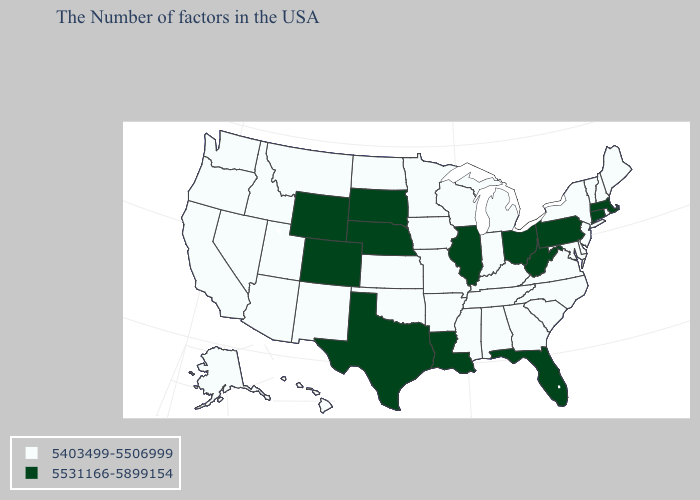What is the value of Minnesota?
Short answer required. 5403499-5506999. Name the states that have a value in the range 5403499-5506999?
Short answer required. Maine, Rhode Island, New Hampshire, Vermont, New York, New Jersey, Delaware, Maryland, Virginia, North Carolina, South Carolina, Georgia, Michigan, Kentucky, Indiana, Alabama, Tennessee, Wisconsin, Mississippi, Missouri, Arkansas, Minnesota, Iowa, Kansas, Oklahoma, North Dakota, New Mexico, Utah, Montana, Arizona, Idaho, Nevada, California, Washington, Oregon, Alaska, Hawaii. What is the value of Iowa?
Be succinct. 5403499-5506999. Name the states that have a value in the range 5531166-5899154?
Concise answer only. Massachusetts, Connecticut, Pennsylvania, West Virginia, Ohio, Florida, Illinois, Louisiana, Nebraska, Texas, South Dakota, Wyoming, Colorado. Name the states that have a value in the range 5531166-5899154?
Write a very short answer. Massachusetts, Connecticut, Pennsylvania, West Virginia, Ohio, Florida, Illinois, Louisiana, Nebraska, Texas, South Dakota, Wyoming, Colorado. Which states have the lowest value in the USA?
Keep it brief. Maine, Rhode Island, New Hampshire, Vermont, New York, New Jersey, Delaware, Maryland, Virginia, North Carolina, South Carolina, Georgia, Michigan, Kentucky, Indiana, Alabama, Tennessee, Wisconsin, Mississippi, Missouri, Arkansas, Minnesota, Iowa, Kansas, Oklahoma, North Dakota, New Mexico, Utah, Montana, Arizona, Idaho, Nevada, California, Washington, Oregon, Alaska, Hawaii. What is the value of Kansas?
Short answer required. 5403499-5506999. Does Florida have the lowest value in the USA?
Give a very brief answer. No. Does Michigan have a higher value than Oregon?
Give a very brief answer. No. Name the states that have a value in the range 5531166-5899154?
Be succinct. Massachusetts, Connecticut, Pennsylvania, West Virginia, Ohio, Florida, Illinois, Louisiana, Nebraska, Texas, South Dakota, Wyoming, Colorado. What is the highest value in the South ?
Answer briefly. 5531166-5899154. 